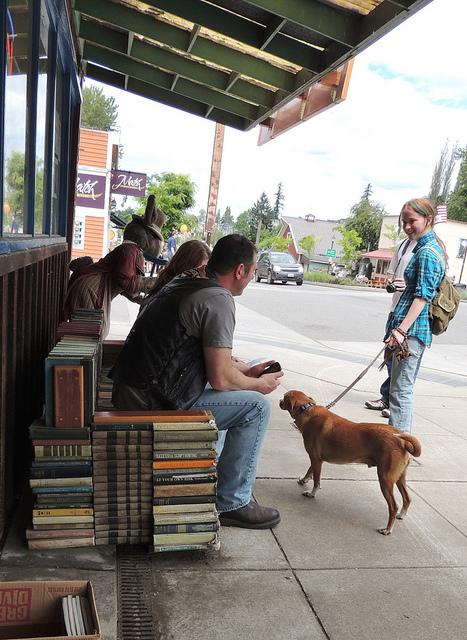Why are they sitting on a pile of books? customized chair 